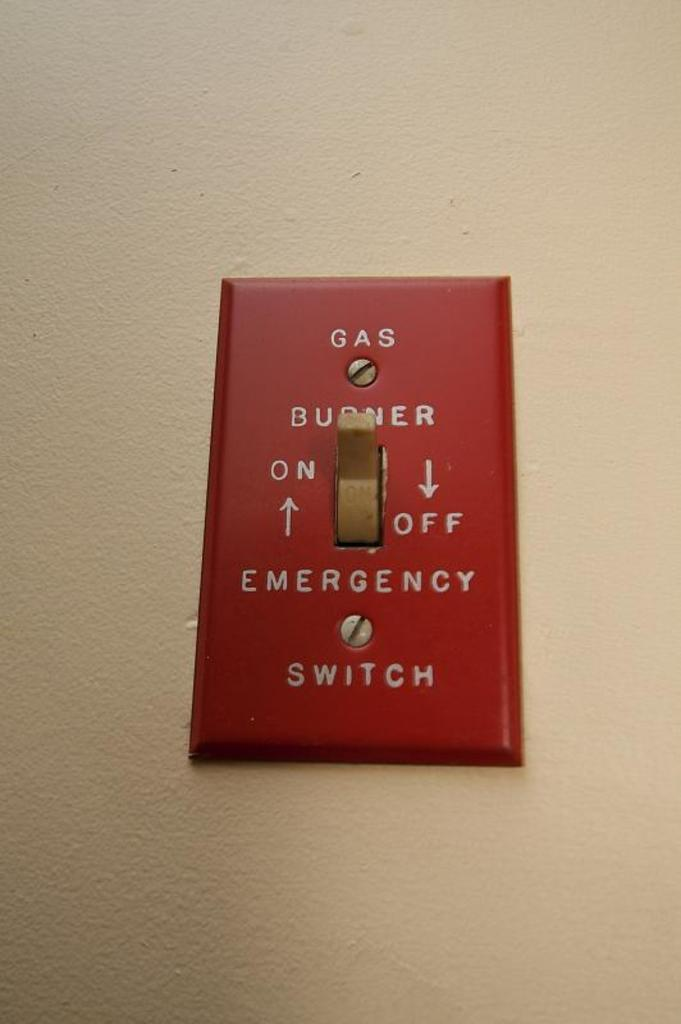<image>
Offer a succinct explanation of the picture presented. A switch which reads Gas Burner Switch on it. 